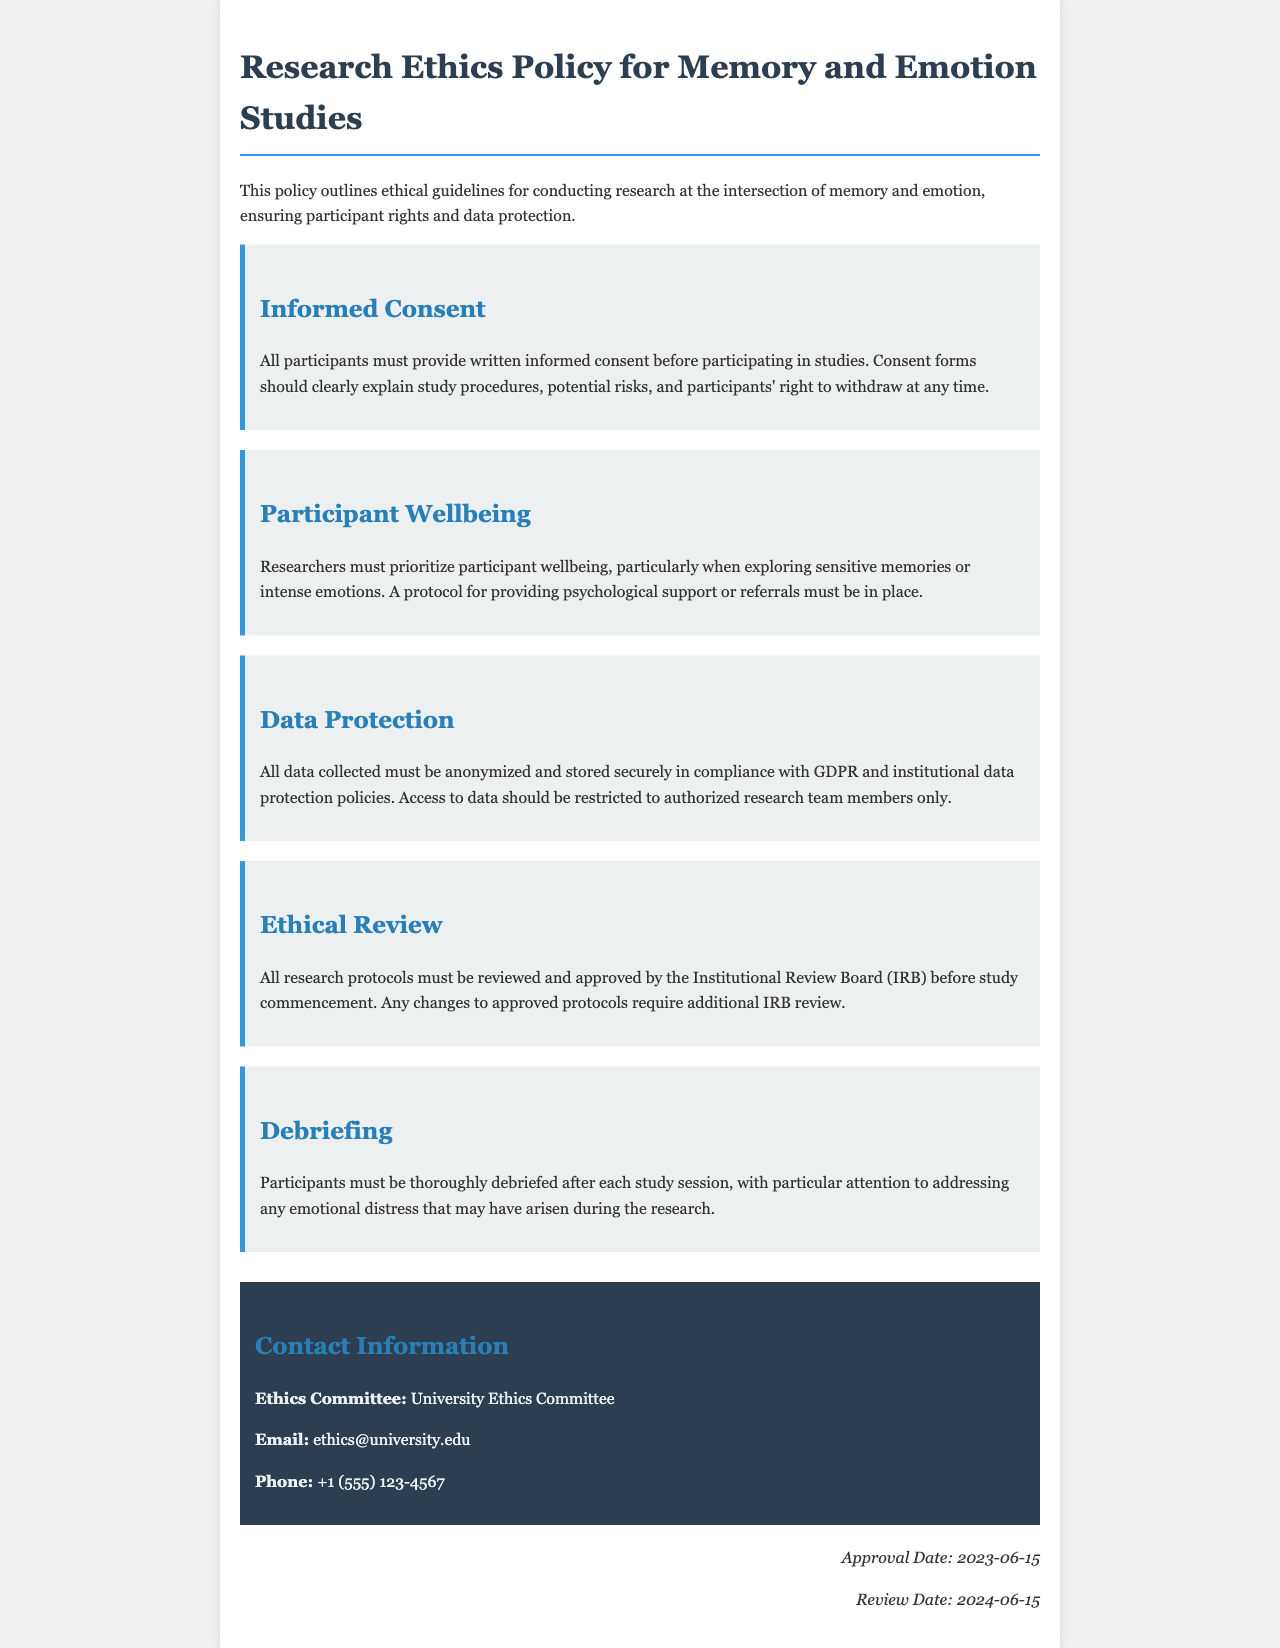What is required before participating in studies? Participants must provide written informed consent before participating in studies, which should explain study procedures and risks.
Answer: Written informed consent What protocol must be in place regarding participant wellbeing? Researchers must have a protocol for providing psychological support or referrals when exploring sensitive memories or intense emotions.
Answer: Psychological support protocol What is the purpose of the Institutional Review Board (IRB) in this document? The IRB must review and approve all research protocols before the study begins, ensuring ethical considerations are met.
Answer: Review and approve protocols What is the email address for the Ethics Committee? The email address is provided in the contact information section of the document.
Answer: ethics@university.edu What kind of data protection must be followed according to the policy? Data must be anonymized and stored securely in compliance with GDPR and institutional data protection policies.
Answer: GDPR compliance How often must the research ethics policy be reviewed? The next review date is set for one year after the approval date, providing regular assessment of the policy.
Answer: 2024-06-15 